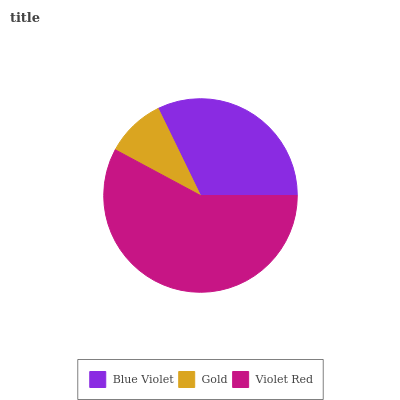Is Gold the minimum?
Answer yes or no. Yes. Is Violet Red the maximum?
Answer yes or no. Yes. Is Violet Red the minimum?
Answer yes or no. No. Is Gold the maximum?
Answer yes or no. No. Is Violet Red greater than Gold?
Answer yes or no. Yes. Is Gold less than Violet Red?
Answer yes or no. Yes. Is Gold greater than Violet Red?
Answer yes or no. No. Is Violet Red less than Gold?
Answer yes or no. No. Is Blue Violet the high median?
Answer yes or no. Yes. Is Blue Violet the low median?
Answer yes or no. Yes. Is Violet Red the high median?
Answer yes or no. No. Is Violet Red the low median?
Answer yes or no. No. 